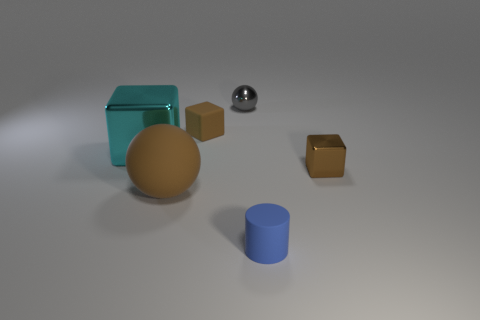Add 2 big brown matte objects. How many objects exist? 8 Subtract all spheres. How many objects are left? 4 Add 2 rubber cylinders. How many rubber cylinders are left? 3 Add 5 big brown matte spheres. How many big brown matte spheres exist? 6 Subtract 0 gray cylinders. How many objects are left? 6 Subtract all tiny red cylinders. Subtract all brown metal objects. How many objects are left? 5 